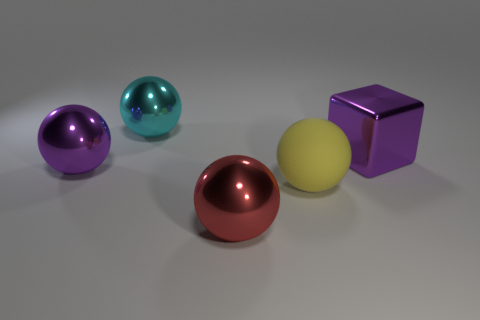What lighting setup might have been used to create the shadows and reflections observed in this image? The shadows and highlights suggest there is a primary light source positioned above the objects, potentially at a slight angle. This light source is responsible for the soft shadows cast to the right of each object and the distinct specular highlights visible on their surfaces. 